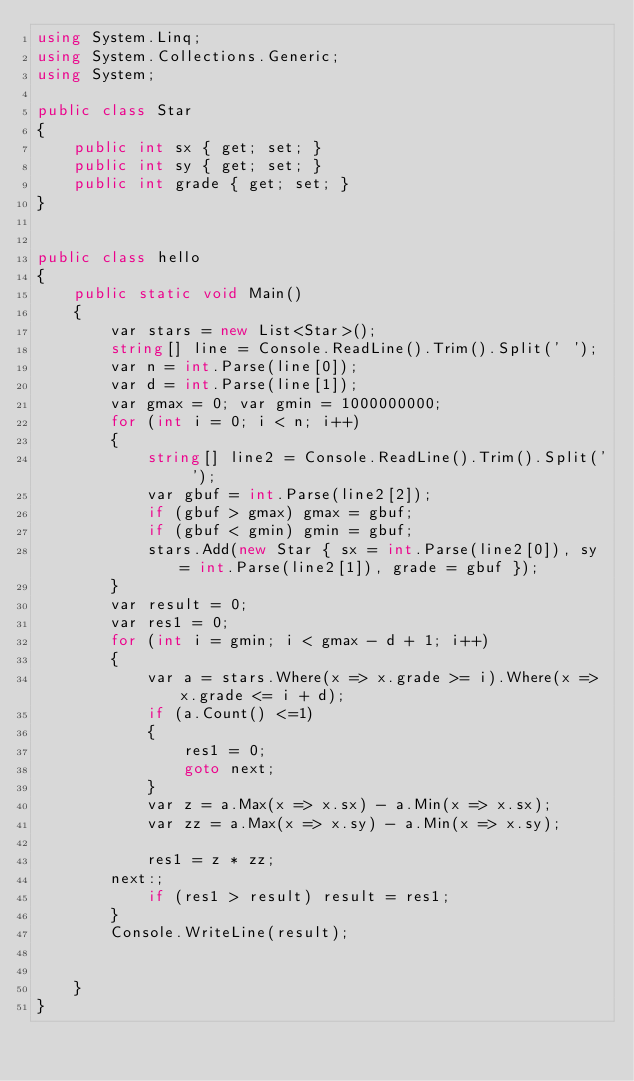Convert code to text. <code><loc_0><loc_0><loc_500><loc_500><_C#_>using System.Linq;
using System.Collections.Generic;
using System;

public class Star
{
    public int sx { get; set; }
    public int sy { get; set; }
    public int grade { get; set; }
}


public class hello
{
    public static void Main()
    {
        var stars = new List<Star>();
        string[] line = Console.ReadLine().Trim().Split(' ');
        var n = int.Parse(line[0]);
        var d = int.Parse(line[1]);
        var gmax = 0; var gmin = 1000000000;
        for (int i = 0; i < n; i++)
        {
            string[] line2 = Console.ReadLine().Trim().Split(' ');
            var gbuf = int.Parse(line2[2]);
            if (gbuf > gmax) gmax = gbuf;
            if (gbuf < gmin) gmin = gbuf;
            stars.Add(new Star { sx = int.Parse(line2[0]), sy = int.Parse(line2[1]), grade = gbuf });
        }
        var result = 0;
        var res1 = 0;
        for (int i = gmin; i < gmax - d + 1; i++)
        {
            var a = stars.Where(x => x.grade >= i).Where(x => x.grade <= i + d);
            if (a.Count() <=1)
            {
                res1 = 0;
                goto next;
            }
            var z = a.Max(x => x.sx) - a.Min(x => x.sx);
            var zz = a.Max(x => x.sy) - a.Min(x => x.sy);

            res1 = z * zz;
        next:;
            if (res1 > result) result = res1;
        }
        Console.WriteLine(result);


    }
}</code> 